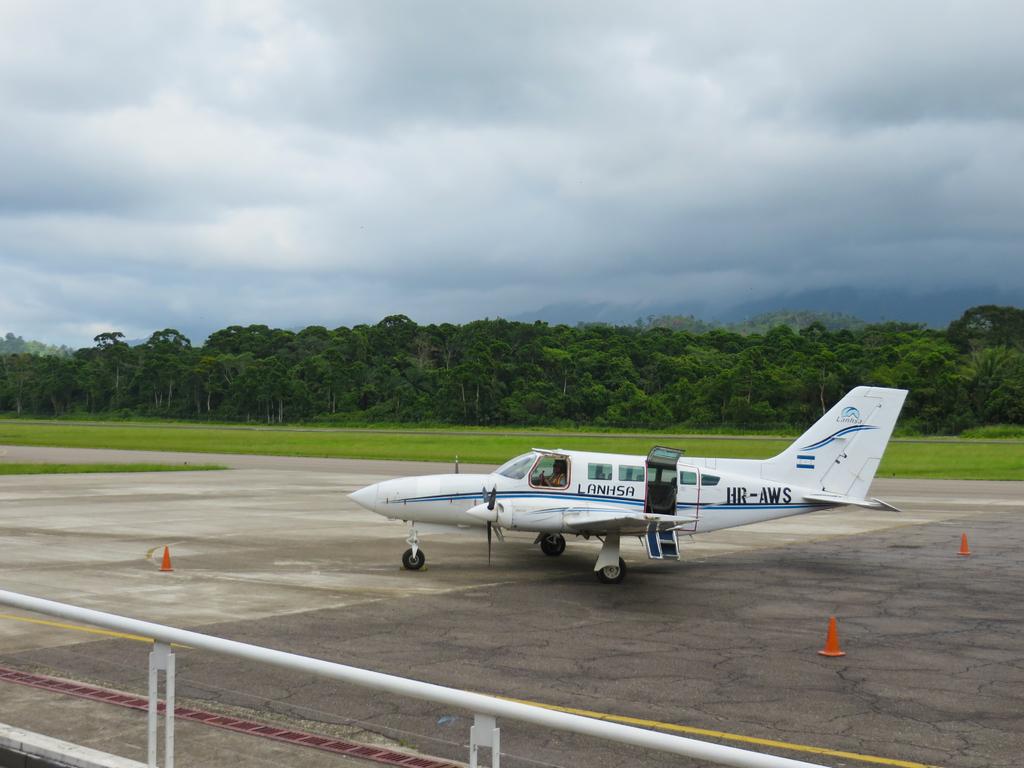What are the letters after hr?
Ensure brevity in your answer.  Aws. What is the plane number?
Offer a very short reply. Hr-aws. 